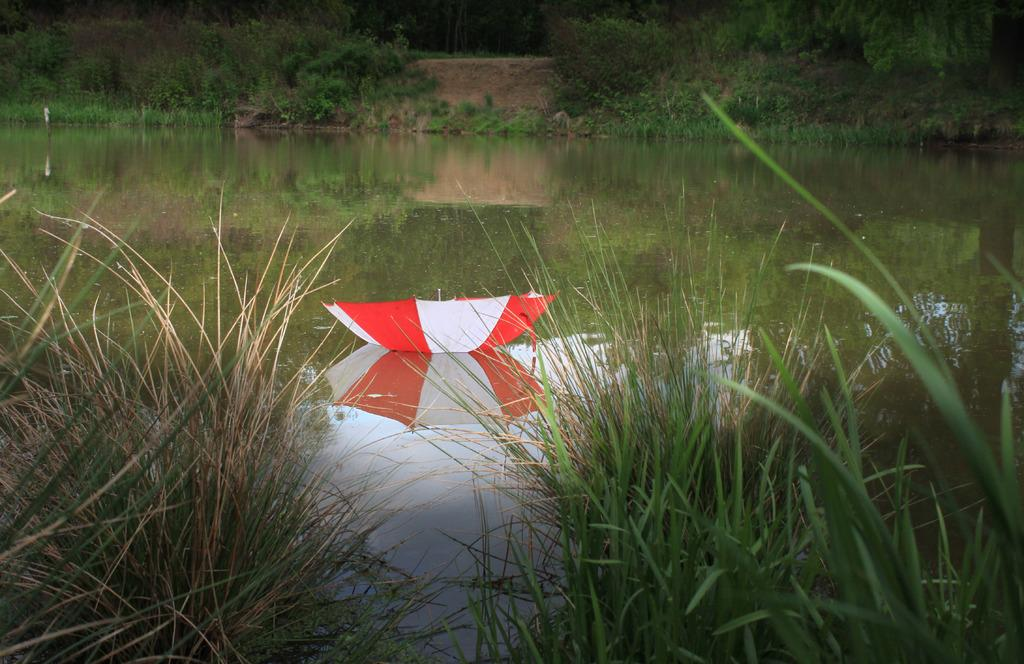What is the primary element in the picture? There is water in the picture. What object can be seen in the water? There is an umbrella present in the water. What type of vegetation is visible in the image? There are trees in the image. What type of ground cover is present in the image? There is grass visible in the image. What is the solution to the riddle hidden in the image? There is no riddle present in the image, so there is no solution to find. 